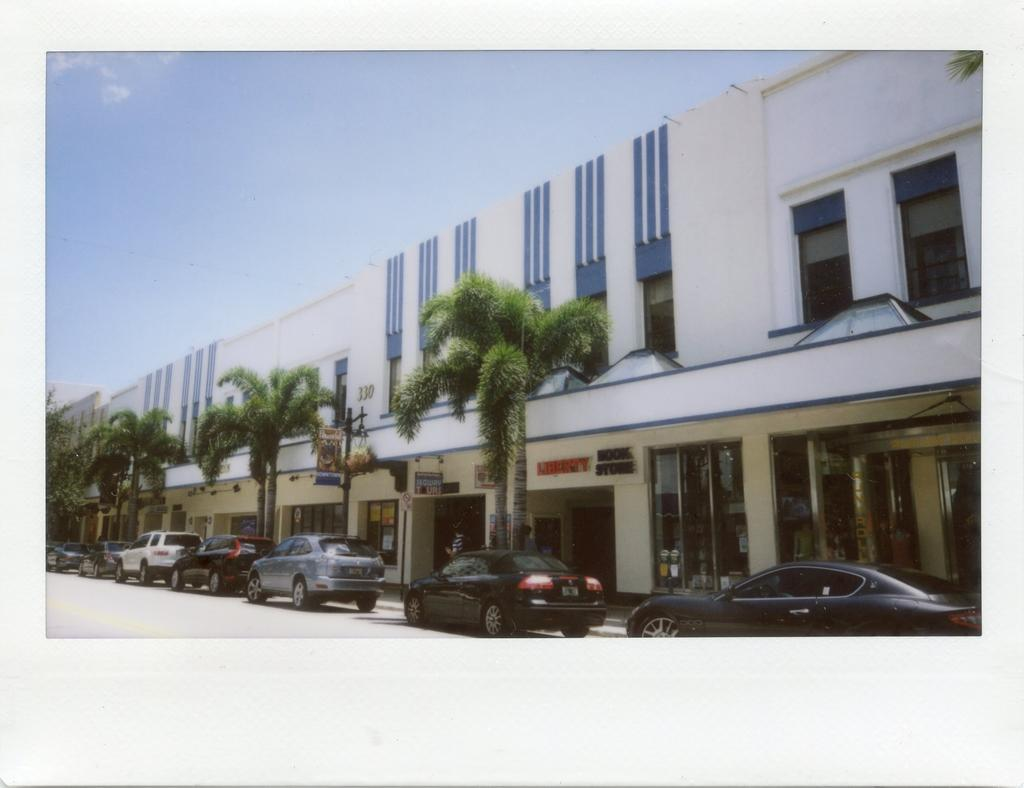What type of vegetation can be seen in the image? There are trees in the image. What is located in front of the building in the image? There are cars in front of a building in the image. What is visible at the top of the image? The sky is visible at the top of the image. What type of clocks can be seen hanging from the trees in the image? There are no clocks visible in the image, and clocks are not hanging from the trees. Who is the manager of the building in the image? The image does not provide information about the building's manager, so it cannot be determined from the image. 